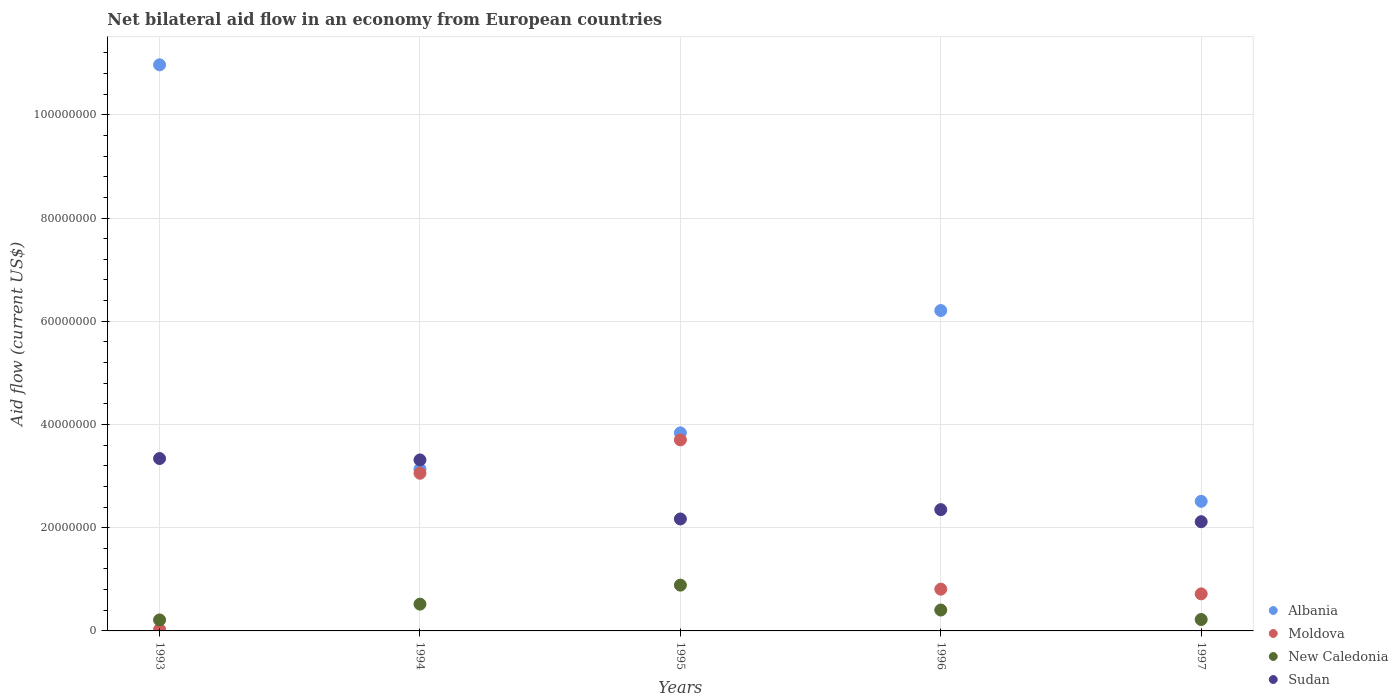Is the number of dotlines equal to the number of legend labels?
Keep it short and to the point. Yes. What is the net bilateral aid flow in New Caledonia in 1996?
Provide a short and direct response. 4.05e+06. Across all years, what is the maximum net bilateral aid flow in Albania?
Your answer should be very brief. 1.10e+08. Across all years, what is the minimum net bilateral aid flow in New Caledonia?
Your answer should be very brief. 2.13e+06. In which year was the net bilateral aid flow in Sudan maximum?
Provide a succinct answer. 1993. What is the total net bilateral aid flow in Sudan in the graph?
Provide a short and direct response. 1.33e+08. What is the difference between the net bilateral aid flow in Moldova in 1993 and that in 1996?
Your answer should be very brief. -7.81e+06. What is the difference between the net bilateral aid flow in Albania in 1994 and the net bilateral aid flow in Sudan in 1995?
Ensure brevity in your answer.  9.67e+06. What is the average net bilateral aid flow in Sudan per year?
Your answer should be compact. 2.66e+07. In the year 1997, what is the difference between the net bilateral aid flow in Albania and net bilateral aid flow in Moldova?
Your response must be concise. 1.79e+07. What is the ratio of the net bilateral aid flow in Moldova in 1993 to that in 1997?
Make the answer very short. 0.04. Is the net bilateral aid flow in New Caledonia in 1995 less than that in 1997?
Provide a short and direct response. No. What is the difference between the highest and the second highest net bilateral aid flow in Sudan?
Keep it short and to the point. 2.70e+05. What is the difference between the highest and the lowest net bilateral aid flow in Albania?
Provide a short and direct response. 8.46e+07. Is it the case that in every year, the sum of the net bilateral aid flow in Albania and net bilateral aid flow in New Caledonia  is greater than the net bilateral aid flow in Sudan?
Make the answer very short. Yes. Does the net bilateral aid flow in Albania monotonically increase over the years?
Provide a short and direct response. No. Is the net bilateral aid flow in Moldova strictly greater than the net bilateral aid flow in Sudan over the years?
Give a very brief answer. No. How many dotlines are there?
Ensure brevity in your answer.  4. What is the difference between two consecutive major ticks on the Y-axis?
Offer a very short reply. 2.00e+07. Are the values on the major ticks of Y-axis written in scientific E-notation?
Keep it short and to the point. No. Does the graph contain any zero values?
Your response must be concise. No. Does the graph contain grids?
Offer a terse response. Yes. Where does the legend appear in the graph?
Your answer should be compact. Bottom right. How many legend labels are there?
Make the answer very short. 4. What is the title of the graph?
Keep it short and to the point. Net bilateral aid flow in an economy from European countries. Does "Fragile and conflict affected situations" appear as one of the legend labels in the graph?
Your answer should be very brief. No. What is the Aid flow (current US$) of Albania in 1993?
Ensure brevity in your answer.  1.10e+08. What is the Aid flow (current US$) in Moldova in 1993?
Ensure brevity in your answer.  2.80e+05. What is the Aid flow (current US$) in New Caledonia in 1993?
Give a very brief answer. 2.13e+06. What is the Aid flow (current US$) in Sudan in 1993?
Offer a very short reply. 3.34e+07. What is the Aid flow (current US$) in Albania in 1994?
Your answer should be very brief. 3.14e+07. What is the Aid flow (current US$) of Moldova in 1994?
Give a very brief answer. 3.06e+07. What is the Aid flow (current US$) in New Caledonia in 1994?
Provide a short and direct response. 5.19e+06. What is the Aid flow (current US$) in Sudan in 1994?
Keep it short and to the point. 3.31e+07. What is the Aid flow (current US$) in Albania in 1995?
Provide a succinct answer. 3.84e+07. What is the Aid flow (current US$) in Moldova in 1995?
Your answer should be compact. 3.70e+07. What is the Aid flow (current US$) in New Caledonia in 1995?
Provide a succinct answer. 8.87e+06. What is the Aid flow (current US$) of Sudan in 1995?
Provide a succinct answer. 2.17e+07. What is the Aid flow (current US$) of Albania in 1996?
Your answer should be compact. 6.21e+07. What is the Aid flow (current US$) of Moldova in 1996?
Offer a terse response. 8.09e+06. What is the Aid flow (current US$) in New Caledonia in 1996?
Offer a terse response. 4.05e+06. What is the Aid flow (current US$) of Sudan in 1996?
Your answer should be very brief. 2.35e+07. What is the Aid flow (current US$) of Albania in 1997?
Offer a terse response. 2.51e+07. What is the Aid flow (current US$) in Moldova in 1997?
Offer a terse response. 7.18e+06. What is the Aid flow (current US$) of New Caledonia in 1997?
Ensure brevity in your answer.  2.21e+06. What is the Aid flow (current US$) in Sudan in 1997?
Your answer should be very brief. 2.12e+07. Across all years, what is the maximum Aid flow (current US$) of Albania?
Keep it short and to the point. 1.10e+08. Across all years, what is the maximum Aid flow (current US$) of Moldova?
Offer a terse response. 3.70e+07. Across all years, what is the maximum Aid flow (current US$) of New Caledonia?
Ensure brevity in your answer.  8.87e+06. Across all years, what is the maximum Aid flow (current US$) in Sudan?
Give a very brief answer. 3.34e+07. Across all years, what is the minimum Aid flow (current US$) of Albania?
Give a very brief answer. 2.51e+07. Across all years, what is the minimum Aid flow (current US$) of New Caledonia?
Your answer should be compact. 2.13e+06. Across all years, what is the minimum Aid flow (current US$) of Sudan?
Your response must be concise. 2.12e+07. What is the total Aid flow (current US$) of Albania in the graph?
Offer a very short reply. 2.67e+08. What is the total Aid flow (current US$) in Moldova in the graph?
Provide a short and direct response. 8.31e+07. What is the total Aid flow (current US$) in New Caledonia in the graph?
Offer a very short reply. 2.24e+07. What is the total Aid flow (current US$) of Sudan in the graph?
Provide a short and direct response. 1.33e+08. What is the difference between the Aid flow (current US$) in Albania in 1993 and that in 1994?
Offer a terse response. 7.83e+07. What is the difference between the Aid flow (current US$) of Moldova in 1993 and that in 1994?
Give a very brief answer. -3.03e+07. What is the difference between the Aid flow (current US$) of New Caledonia in 1993 and that in 1994?
Offer a terse response. -3.06e+06. What is the difference between the Aid flow (current US$) of Albania in 1993 and that in 1995?
Make the answer very short. 7.13e+07. What is the difference between the Aid flow (current US$) of Moldova in 1993 and that in 1995?
Give a very brief answer. -3.67e+07. What is the difference between the Aid flow (current US$) of New Caledonia in 1993 and that in 1995?
Provide a short and direct response. -6.74e+06. What is the difference between the Aid flow (current US$) in Sudan in 1993 and that in 1995?
Provide a short and direct response. 1.17e+07. What is the difference between the Aid flow (current US$) of Albania in 1993 and that in 1996?
Provide a short and direct response. 4.76e+07. What is the difference between the Aid flow (current US$) in Moldova in 1993 and that in 1996?
Your answer should be compact. -7.81e+06. What is the difference between the Aid flow (current US$) of New Caledonia in 1993 and that in 1996?
Your answer should be compact. -1.92e+06. What is the difference between the Aid flow (current US$) in Sudan in 1993 and that in 1996?
Offer a very short reply. 9.90e+06. What is the difference between the Aid flow (current US$) of Albania in 1993 and that in 1997?
Provide a short and direct response. 8.46e+07. What is the difference between the Aid flow (current US$) in Moldova in 1993 and that in 1997?
Offer a terse response. -6.90e+06. What is the difference between the Aid flow (current US$) in Sudan in 1993 and that in 1997?
Make the answer very short. 1.22e+07. What is the difference between the Aid flow (current US$) of Albania in 1994 and that in 1995?
Ensure brevity in your answer.  -7.01e+06. What is the difference between the Aid flow (current US$) in Moldova in 1994 and that in 1995?
Your answer should be very brief. -6.46e+06. What is the difference between the Aid flow (current US$) of New Caledonia in 1994 and that in 1995?
Provide a short and direct response. -3.68e+06. What is the difference between the Aid flow (current US$) of Sudan in 1994 and that in 1995?
Give a very brief answer. 1.14e+07. What is the difference between the Aid flow (current US$) in Albania in 1994 and that in 1996?
Your response must be concise. -3.07e+07. What is the difference between the Aid flow (current US$) of Moldova in 1994 and that in 1996?
Offer a very short reply. 2.25e+07. What is the difference between the Aid flow (current US$) of New Caledonia in 1994 and that in 1996?
Give a very brief answer. 1.14e+06. What is the difference between the Aid flow (current US$) in Sudan in 1994 and that in 1996?
Provide a succinct answer. 9.63e+06. What is the difference between the Aid flow (current US$) of Albania in 1994 and that in 1997?
Ensure brevity in your answer.  6.25e+06. What is the difference between the Aid flow (current US$) of Moldova in 1994 and that in 1997?
Ensure brevity in your answer.  2.34e+07. What is the difference between the Aid flow (current US$) of New Caledonia in 1994 and that in 1997?
Your response must be concise. 2.98e+06. What is the difference between the Aid flow (current US$) of Sudan in 1994 and that in 1997?
Your response must be concise. 1.20e+07. What is the difference between the Aid flow (current US$) in Albania in 1995 and that in 1996?
Your response must be concise. -2.37e+07. What is the difference between the Aid flow (current US$) in Moldova in 1995 and that in 1996?
Make the answer very short. 2.89e+07. What is the difference between the Aid flow (current US$) of New Caledonia in 1995 and that in 1996?
Your answer should be very brief. 4.82e+06. What is the difference between the Aid flow (current US$) of Sudan in 1995 and that in 1996?
Ensure brevity in your answer.  -1.81e+06. What is the difference between the Aid flow (current US$) of Albania in 1995 and that in 1997?
Your answer should be very brief. 1.33e+07. What is the difference between the Aid flow (current US$) in Moldova in 1995 and that in 1997?
Your answer should be very brief. 2.98e+07. What is the difference between the Aid flow (current US$) of New Caledonia in 1995 and that in 1997?
Offer a very short reply. 6.66e+06. What is the difference between the Aid flow (current US$) in Sudan in 1995 and that in 1997?
Provide a short and direct response. 5.30e+05. What is the difference between the Aid flow (current US$) in Albania in 1996 and that in 1997?
Provide a short and direct response. 3.70e+07. What is the difference between the Aid flow (current US$) of Moldova in 1996 and that in 1997?
Keep it short and to the point. 9.10e+05. What is the difference between the Aid flow (current US$) in New Caledonia in 1996 and that in 1997?
Provide a succinct answer. 1.84e+06. What is the difference between the Aid flow (current US$) in Sudan in 1996 and that in 1997?
Offer a very short reply. 2.34e+06. What is the difference between the Aid flow (current US$) of Albania in 1993 and the Aid flow (current US$) of Moldova in 1994?
Keep it short and to the point. 7.91e+07. What is the difference between the Aid flow (current US$) in Albania in 1993 and the Aid flow (current US$) in New Caledonia in 1994?
Make the answer very short. 1.04e+08. What is the difference between the Aid flow (current US$) in Albania in 1993 and the Aid flow (current US$) in Sudan in 1994?
Your response must be concise. 7.66e+07. What is the difference between the Aid flow (current US$) in Moldova in 1993 and the Aid flow (current US$) in New Caledonia in 1994?
Offer a terse response. -4.91e+06. What is the difference between the Aid flow (current US$) of Moldova in 1993 and the Aid flow (current US$) of Sudan in 1994?
Offer a terse response. -3.28e+07. What is the difference between the Aid flow (current US$) of New Caledonia in 1993 and the Aid flow (current US$) of Sudan in 1994?
Keep it short and to the point. -3.10e+07. What is the difference between the Aid flow (current US$) in Albania in 1993 and the Aid flow (current US$) in Moldova in 1995?
Offer a very short reply. 7.27e+07. What is the difference between the Aid flow (current US$) in Albania in 1993 and the Aid flow (current US$) in New Caledonia in 1995?
Offer a very short reply. 1.01e+08. What is the difference between the Aid flow (current US$) in Albania in 1993 and the Aid flow (current US$) in Sudan in 1995?
Your answer should be very brief. 8.80e+07. What is the difference between the Aid flow (current US$) in Moldova in 1993 and the Aid flow (current US$) in New Caledonia in 1995?
Make the answer very short. -8.59e+06. What is the difference between the Aid flow (current US$) of Moldova in 1993 and the Aid flow (current US$) of Sudan in 1995?
Your response must be concise. -2.14e+07. What is the difference between the Aid flow (current US$) in New Caledonia in 1993 and the Aid flow (current US$) in Sudan in 1995?
Your answer should be very brief. -1.96e+07. What is the difference between the Aid flow (current US$) of Albania in 1993 and the Aid flow (current US$) of Moldova in 1996?
Give a very brief answer. 1.02e+08. What is the difference between the Aid flow (current US$) of Albania in 1993 and the Aid flow (current US$) of New Caledonia in 1996?
Provide a succinct answer. 1.06e+08. What is the difference between the Aid flow (current US$) in Albania in 1993 and the Aid flow (current US$) in Sudan in 1996?
Ensure brevity in your answer.  8.62e+07. What is the difference between the Aid flow (current US$) in Moldova in 1993 and the Aid flow (current US$) in New Caledonia in 1996?
Provide a succinct answer. -3.77e+06. What is the difference between the Aid flow (current US$) of Moldova in 1993 and the Aid flow (current US$) of Sudan in 1996?
Your answer should be very brief. -2.32e+07. What is the difference between the Aid flow (current US$) in New Caledonia in 1993 and the Aid flow (current US$) in Sudan in 1996?
Keep it short and to the point. -2.14e+07. What is the difference between the Aid flow (current US$) of Albania in 1993 and the Aid flow (current US$) of Moldova in 1997?
Your answer should be compact. 1.02e+08. What is the difference between the Aid flow (current US$) of Albania in 1993 and the Aid flow (current US$) of New Caledonia in 1997?
Offer a terse response. 1.07e+08. What is the difference between the Aid flow (current US$) of Albania in 1993 and the Aid flow (current US$) of Sudan in 1997?
Keep it short and to the point. 8.85e+07. What is the difference between the Aid flow (current US$) of Moldova in 1993 and the Aid flow (current US$) of New Caledonia in 1997?
Offer a terse response. -1.93e+06. What is the difference between the Aid flow (current US$) in Moldova in 1993 and the Aid flow (current US$) in Sudan in 1997?
Ensure brevity in your answer.  -2.09e+07. What is the difference between the Aid flow (current US$) in New Caledonia in 1993 and the Aid flow (current US$) in Sudan in 1997?
Your response must be concise. -1.90e+07. What is the difference between the Aid flow (current US$) of Albania in 1994 and the Aid flow (current US$) of Moldova in 1995?
Provide a short and direct response. -5.65e+06. What is the difference between the Aid flow (current US$) of Albania in 1994 and the Aid flow (current US$) of New Caledonia in 1995?
Ensure brevity in your answer.  2.25e+07. What is the difference between the Aid flow (current US$) in Albania in 1994 and the Aid flow (current US$) in Sudan in 1995?
Your answer should be compact. 9.67e+06. What is the difference between the Aid flow (current US$) in Moldova in 1994 and the Aid flow (current US$) in New Caledonia in 1995?
Ensure brevity in your answer.  2.17e+07. What is the difference between the Aid flow (current US$) of Moldova in 1994 and the Aid flow (current US$) of Sudan in 1995?
Make the answer very short. 8.86e+06. What is the difference between the Aid flow (current US$) in New Caledonia in 1994 and the Aid flow (current US$) in Sudan in 1995?
Ensure brevity in your answer.  -1.65e+07. What is the difference between the Aid flow (current US$) of Albania in 1994 and the Aid flow (current US$) of Moldova in 1996?
Ensure brevity in your answer.  2.33e+07. What is the difference between the Aid flow (current US$) in Albania in 1994 and the Aid flow (current US$) in New Caledonia in 1996?
Ensure brevity in your answer.  2.73e+07. What is the difference between the Aid flow (current US$) in Albania in 1994 and the Aid flow (current US$) in Sudan in 1996?
Provide a short and direct response. 7.86e+06. What is the difference between the Aid flow (current US$) in Moldova in 1994 and the Aid flow (current US$) in New Caledonia in 1996?
Keep it short and to the point. 2.65e+07. What is the difference between the Aid flow (current US$) of Moldova in 1994 and the Aid flow (current US$) of Sudan in 1996?
Your response must be concise. 7.05e+06. What is the difference between the Aid flow (current US$) of New Caledonia in 1994 and the Aid flow (current US$) of Sudan in 1996?
Your answer should be very brief. -1.83e+07. What is the difference between the Aid flow (current US$) of Albania in 1994 and the Aid flow (current US$) of Moldova in 1997?
Offer a very short reply. 2.42e+07. What is the difference between the Aid flow (current US$) in Albania in 1994 and the Aid flow (current US$) in New Caledonia in 1997?
Ensure brevity in your answer.  2.92e+07. What is the difference between the Aid flow (current US$) of Albania in 1994 and the Aid flow (current US$) of Sudan in 1997?
Provide a short and direct response. 1.02e+07. What is the difference between the Aid flow (current US$) in Moldova in 1994 and the Aid flow (current US$) in New Caledonia in 1997?
Your answer should be compact. 2.83e+07. What is the difference between the Aid flow (current US$) in Moldova in 1994 and the Aid flow (current US$) in Sudan in 1997?
Provide a succinct answer. 9.39e+06. What is the difference between the Aid flow (current US$) of New Caledonia in 1994 and the Aid flow (current US$) of Sudan in 1997?
Ensure brevity in your answer.  -1.60e+07. What is the difference between the Aid flow (current US$) in Albania in 1995 and the Aid flow (current US$) in Moldova in 1996?
Provide a short and direct response. 3.03e+07. What is the difference between the Aid flow (current US$) of Albania in 1995 and the Aid flow (current US$) of New Caledonia in 1996?
Provide a succinct answer. 3.43e+07. What is the difference between the Aid flow (current US$) in Albania in 1995 and the Aid flow (current US$) in Sudan in 1996?
Keep it short and to the point. 1.49e+07. What is the difference between the Aid flow (current US$) in Moldova in 1995 and the Aid flow (current US$) in New Caledonia in 1996?
Offer a very short reply. 3.30e+07. What is the difference between the Aid flow (current US$) of Moldova in 1995 and the Aid flow (current US$) of Sudan in 1996?
Provide a short and direct response. 1.35e+07. What is the difference between the Aid flow (current US$) of New Caledonia in 1995 and the Aid flow (current US$) of Sudan in 1996?
Provide a short and direct response. -1.46e+07. What is the difference between the Aid flow (current US$) of Albania in 1995 and the Aid flow (current US$) of Moldova in 1997?
Your response must be concise. 3.12e+07. What is the difference between the Aid flow (current US$) of Albania in 1995 and the Aid flow (current US$) of New Caledonia in 1997?
Provide a short and direct response. 3.62e+07. What is the difference between the Aid flow (current US$) of Albania in 1995 and the Aid flow (current US$) of Sudan in 1997?
Your response must be concise. 1.72e+07. What is the difference between the Aid flow (current US$) of Moldova in 1995 and the Aid flow (current US$) of New Caledonia in 1997?
Ensure brevity in your answer.  3.48e+07. What is the difference between the Aid flow (current US$) of Moldova in 1995 and the Aid flow (current US$) of Sudan in 1997?
Ensure brevity in your answer.  1.58e+07. What is the difference between the Aid flow (current US$) of New Caledonia in 1995 and the Aid flow (current US$) of Sudan in 1997?
Your response must be concise. -1.23e+07. What is the difference between the Aid flow (current US$) in Albania in 1996 and the Aid flow (current US$) in Moldova in 1997?
Your answer should be very brief. 5.49e+07. What is the difference between the Aid flow (current US$) of Albania in 1996 and the Aid flow (current US$) of New Caledonia in 1997?
Offer a terse response. 5.99e+07. What is the difference between the Aid flow (current US$) in Albania in 1996 and the Aid flow (current US$) in Sudan in 1997?
Offer a terse response. 4.09e+07. What is the difference between the Aid flow (current US$) of Moldova in 1996 and the Aid flow (current US$) of New Caledonia in 1997?
Your answer should be compact. 5.88e+06. What is the difference between the Aid flow (current US$) in Moldova in 1996 and the Aid flow (current US$) in Sudan in 1997?
Your answer should be very brief. -1.31e+07. What is the difference between the Aid flow (current US$) in New Caledonia in 1996 and the Aid flow (current US$) in Sudan in 1997?
Ensure brevity in your answer.  -1.71e+07. What is the average Aid flow (current US$) in Albania per year?
Your response must be concise. 5.33e+07. What is the average Aid flow (current US$) of Moldova per year?
Offer a terse response. 1.66e+07. What is the average Aid flow (current US$) in New Caledonia per year?
Your answer should be very brief. 4.49e+06. What is the average Aid flow (current US$) in Sudan per year?
Make the answer very short. 2.66e+07. In the year 1993, what is the difference between the Aid flow (current US$) of Albania and Aid flow (current US$) of Moldova?
Offer a terse response. 1.09e+08. In the year 1993, what is the difference between the Aid flow (current US$) of Albania and Aid flow (current US$) of New Caledonia?
Offer a terse response. 1.08e+08. In the year 1993, what is the difference between the Aid flow (current US$) of Albania and Aid flow (current US$) of Sudan?
Your response must be concise. 7.63e+07. In the year 1993, what is the difference between the Aid flow (current US$) in Moldova and Aid flow (current US$) in New Caledonia?
Provide a succinct answer. -1.85e+06. In the year 1993, what is the difference between the Aid flow (current US$) in Moldova and Aid flow (current US$) in Sudan?
Provide a succinct answer. -3.31e+07. In the year 1993, what is the difference between the Aid flow (current US$) of New Caledonia and Aid flow (current US$) of Sudan?
Provide a short and direct response. -3.13e+07. In the year 1994, what is the difference between the Aid flow (current US$) of Albania and Aid flow (current US$) of Moldova?
Keep it short and to the point. 8.10e+05. In the year 1994, what is the difference between the Aid flow (current US$) of Albania and Aid flow (current US$) of New Caledonia?
Keep it short and to the point. 2.62e+07. In the year 1994, what is the difference between the Aid flow (current US$) of Albania and Aid flow (current US$) of Sudan?
Make the answer very short. -1.77e+06. In the year 1994, what is the difference between the Aid flow (current US$) of Moldova and Aid flow (current US$) of New Caledonia?
Your response must be concise. 2.54e+07. In the year 1994, what is the difference between the Aid flow (current US$) in Moldova and Aid flow (current US$) in Sudan?
Make the answer very short. -2.58e+06. In the year 1994, what is the difference between the Aid flow (current US$) of New Caledonia and Aid flow (current US$) of Sudan?
Your response must be concise. -2.79e+07. In the year 1995, what is the difference between the Aid flow (current US$) in Albania and Aid flow (current US$) in Moldova?
Your answer should be compact. 1.36e+06. In the year 1995, what is the difference between the Aid flow (current US$) of Albania and Aid flow (current US$) of New Caledonia?
Your response must be concise. 2.95e+07. In the year 1995, what is the difference between the Aid flow (current US$) of Albania and Aid flow (current US$) of Sudan?
Give a very brief answer. 1.67e+07. In the year 1995, what is the difference between the Aid flow (current US$) of Moldova and Aid flow (current US$) of New Caledonia?
Your answer should be compact. 2.81e+07. In the year 1995, what is the difference between the Aid flow (current US$) of Moldova and Aid flow (current US$) of Sudan?
Ensure brevity in your answer.  1.53e+07. In the year 1995, what is the difference between the Aid flow (current US$) of New Caledonia and Aid flow (current US$) of Sudan?
Your answer should be compact. -1.28e+07. In the year 1996, what is the difference between the Aid flow (current US$) in Albania and Aid flow (current US$) in Moldova?
Your response must be concise. 5.40e+07. In the year 1996, what is the difference between the Aid flow (current US$) in Albania and Aid flow (current US$) in New Caledonia?
Give a very brief answer. 5.80e+07. In the year 1996, what is the difference between the Aid flow (current US$) in Albania and Aid flow (current US$) in Sudan?
Your answer should be compact. 3.86e+07. In the year 1996, what is the difference between the Aid flow (current US$) of Moldova and Aid flow (current US$) of New Caledonia?
Provide a succinct answer. 4.04e+06. In the year 1996, what is the difference between the Aid flow (current US$) of Moldova and Aid flow (current US$) of Sudan?
Keep it short and to the point. -1.54e+07. In the year 1996, what is the difference between the Aid flow (current US$) in New Caledonia and Aid flow (current US$) in Sudan?
Provide a short and direct response. -1.94e+07. In the year 1997, what is the difference between the Aid flow (current US$) of Albania and Aid flow (current US$) of Moldova?
Offer a very short reply. 1.79e+07. In the year 1997, what is the difference between the Aid flow (current US$) of Albania and Aid flow (current US$) of New Caledonia?
Make the answer very short. 2.29e+07. In the year 1997, what is the difference between the Aid flow (current US$) of Albania and Aid flow (current US$) of Sudan?
Give a very brief answer. 3.95e+06. In the year 1997, what is the difference between the Aid flow (current US$) of Moldova and Aid flow (current US$) of New Caledonia?
Your answer should be compact. 4.97e+06. In the year 1997, what is the difference between the Aid flow (current US$) of Moldova and Aid flow (current US$) of Sudan?
Provide a short and direct response. -1.40e+07. In the year 1997, what is the difference between the Aid flow (current US$) of New Caledonia and Aid flow (current US$) of Sudan?
Ensure brevity in your answer.  -1.90e+07. What is the ratio of the Aid flow (current US$) of Albania in 1993 to that in 1994?
Offer a very short reply. 3.5. What is the ratio of the Aid flow (current US$) in Moldova in 1993 to that in 1994?
Offer a very short reply. 0.01. What is the ratio of the Aid flow (current US$) in New Caledonia in 1993 to that in 1994?
Provide a succinct answer. 0.41. What is the ratio of the Aid flow (current US$) in Sudan in 1993 to that in 1994?
Keep it short and to the point. 1.01. What is the ratio of the Aid flow (current US$) of Albania in 1993 to that in 1995?
Offer a terse response. 2.86. What is the ratio of the Aid flow (current US$) in Moldova in 1993 to that in 1995?
Give a very brief answer. 0.01. What is the ratio of the Aid flow (current US$) in New Caledonia in 1993 to that in 1995?
Your response must be concise. 0.24. What is the ratio of the Aid flow (current US$) in Sudan in 1993 to that in 1995?
Your answer should be very brief. 1.54. What is the ratio of the Aid flow (current US$) of Albania in 1993 to that in 1996?
Offer a terse response. 1.77. What is the ratio of the Aid flow (current US$) of Moldova in 1993 to that in 1996?
Provide a succinct answer. 0.03. What is the ratio of the Aid flow (current US$) of New Caledonia in 1993 to that in 1996?
Your answer should be very brief. 0.53. What is the ratio of the Aid flow (current US$) in Sudan in 1993 to that in 1996?
Your answer should be compact. 1.42. What is the ratio of the Aid flow (current US$) of Albania in 1993 to that in 1997?
Your response must be concise. 4.37. What is the ratio of the Aid flow (current US$) in Moldova in 1993 to that in 1997?
Your answer should be compact. 0.04. What is the ratio of the Aid flow (current US$) in New Caledonia in 1993 to that in 1997?
Make the answer very short. 0.96. What is the ratio of the Aid flow (current US$) in Sudan in 1993 to that in 1997?
Keep it short and to the point. 1.58. What is the ratio of the Aid flow (current US$) in Albania in 1994 to that in 1995?
Provide a short and direct response. 0.82. What is the ratio of the Aid flow (current US$) of Moldova in 1994 to that in 1995?
Make the answer very short. 0.83. What is the ratio of the Aid flow (current US$) in New Caledonia in 1994 to that in 1995?
Provide a succinct answer. 0.59. What is the ratio of the Aid flow (current US$) of Sudan in 1994 to that in 1995?
Give a very brief answer. 1.53. What is the ratio of the Aid flow (current US$) of Albania in 1994 to that in 1996?
Offer a very short reply. 0.51. What is the ratio of the Aid flow (current US$) in Moldova in 1994 to that in 1996?
Provide a succinct answer. 3.78. What is the ratio of the Aid flow (current US$) of New Caledonia in 1994 to that in 1996?
Give a very brief answer. 1.28. What is the ratio of the Aid flow (current US$) of Sudan in 1994 to that in 1996?
Make the answer very short. 1.41. What is the ratio of the Aid flow (current US$) in Albania in 1994 to that in 1997?
Offer a terse response. 1.25. What is the ratio of the Aid flow (current US$) of Moldova in 1994 to that in 1997?
Your answer should be very brief. 4.25. What is the ratio of the Aid flow (current US$) in New Caledonia in 1994 to that in 1997?
Ensure brevity in your answer.  2.35. What is the ratio of the Aid flow (current US$) in Sudan in 1994 to that in 1997?
Provide a short and direct response. 1.57. What is the ratio of the Aid flow (current US$) in Albania in 1995 to that in 1996?
Ensure brevity in your answer.  0.62. What is the ratio of the Aid flow (current US$) in Moldova in 1995 to that in 1996?
Give a very brief answer. 4.57. What is the ratio of the Aid flow (current US$) of New Caledonia in 1995 to that in 1996?
Provide a succinct answer. 2.19. What is the ratio of the Aid flow (current US$) in Sudan in 1995 to that in 1996?
Your answer should be very brief. 0.92. What is the ratio of the Aid flow (current US$) in Albania in 1995 to that in 1997?
Your answer should be very brief. 1.53. What is the ratio of the Aid flow (current US$) of Moldova in 1995 to that in 1997?
Your answer should be compact. 5.15. What is the ratio of the Aid flow (current US$) of New Caledonia in 1995 to that in 1997?
Offer a terse response. 4.01. What is the ratio of the Aid flow (current US$) in Sudan in 1995 to that in 1997?
Give a very brief answer. 1.02. What is the ratio of the Aid flow (current US$) of Albania in 1996 to that in 1997?
Give a very brief answer. 2.47. What is the ratio of the Aid flow (current US$) in Moldova in 1996 to that in 1997?
Offer a very short reply. 1.13. What is the ratio of the Aid flow (current US$) of New Caledonia in 1996 to that in 1997?
Your answer should be compact. 1.83. What is the ratio of the Aid flow (current US$) of Sudan in 1996 to that in 1997?
Your response must be concise. 1.11. What is the difference between the highest and the second highest Aid flow (current US$) in Albania?
Make the answer very short. 4.76e+07. What is the difference between the highest and the second highest Aid flow (current US$) in Moldova?
Offer a very short reply. 6.46e+06. What is the difference between the highest and the second highest Aid flow (current US$) in New Caledonia?
Your answer should be very brief. 3.68e+06. What is the difference between the highest and the second highest Aid flow (current US$) in Sudan?
Offer a very short reply. 2.70e+05. What is the difference between the highest and the lowest Aid flow (current US$) of Albania?
Give a very brief answer. 8.46e+07. What is the difference between the highest and the lowest Aid flow (current US$) of Moldova?
Your answer should be very brief. 3.67e+07. What is the difference between the highest and the lowest Aid flow (current US$) in New Caledonia?
Your answer should be very brief. 6.74e+06. What is the difference between the highest and the lowest Aid flow (current US$) of Sudan?
Offer a terse response. 1.22e+07. 